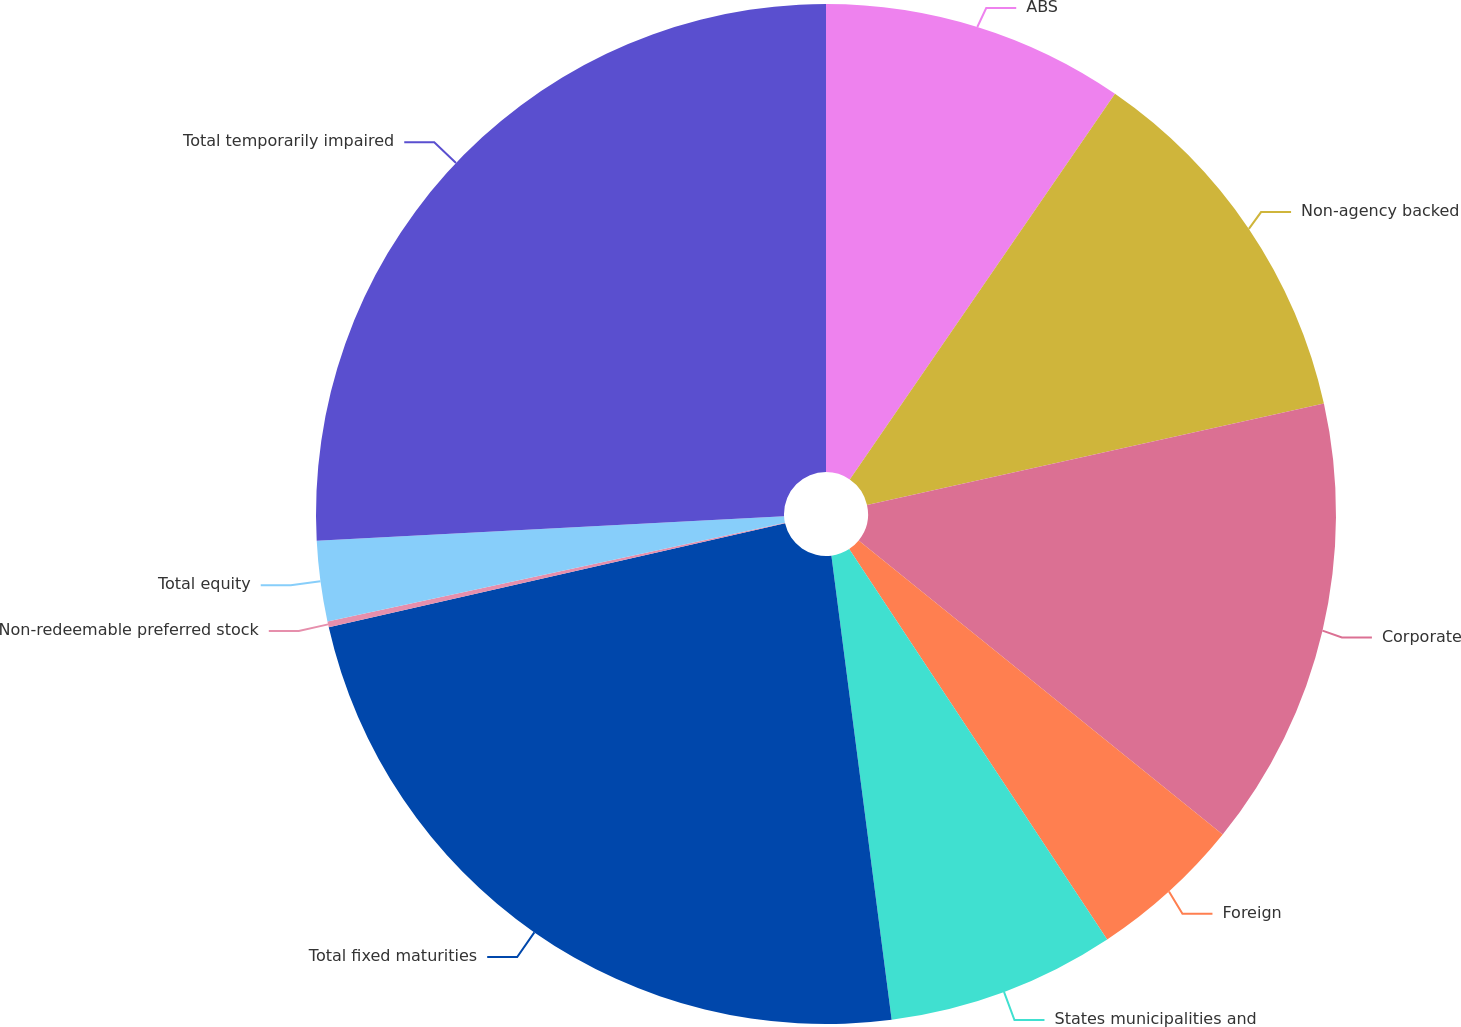Convert chart. <chart><loc_0><loc_0><loc_500><loc_500><pie_chart><fcel>ABS<fcel>Non-agency backed<fcel>Corporate<fcel>Foreign<fcel>States municipalities and<fcel>Total fixed maturities<fcel>Non-redeemable preferred stock<fcel>Total equity<fcel>Total temporarily impaired<nl><fcel>9.59%<fcel>11.94%<fcel>14.29%<fcel>4.89%<fcel>7.24%<fcel>23.49%<fcel>0.19%<fcel>2.54%<fcel>25.84%<nl></chart> 